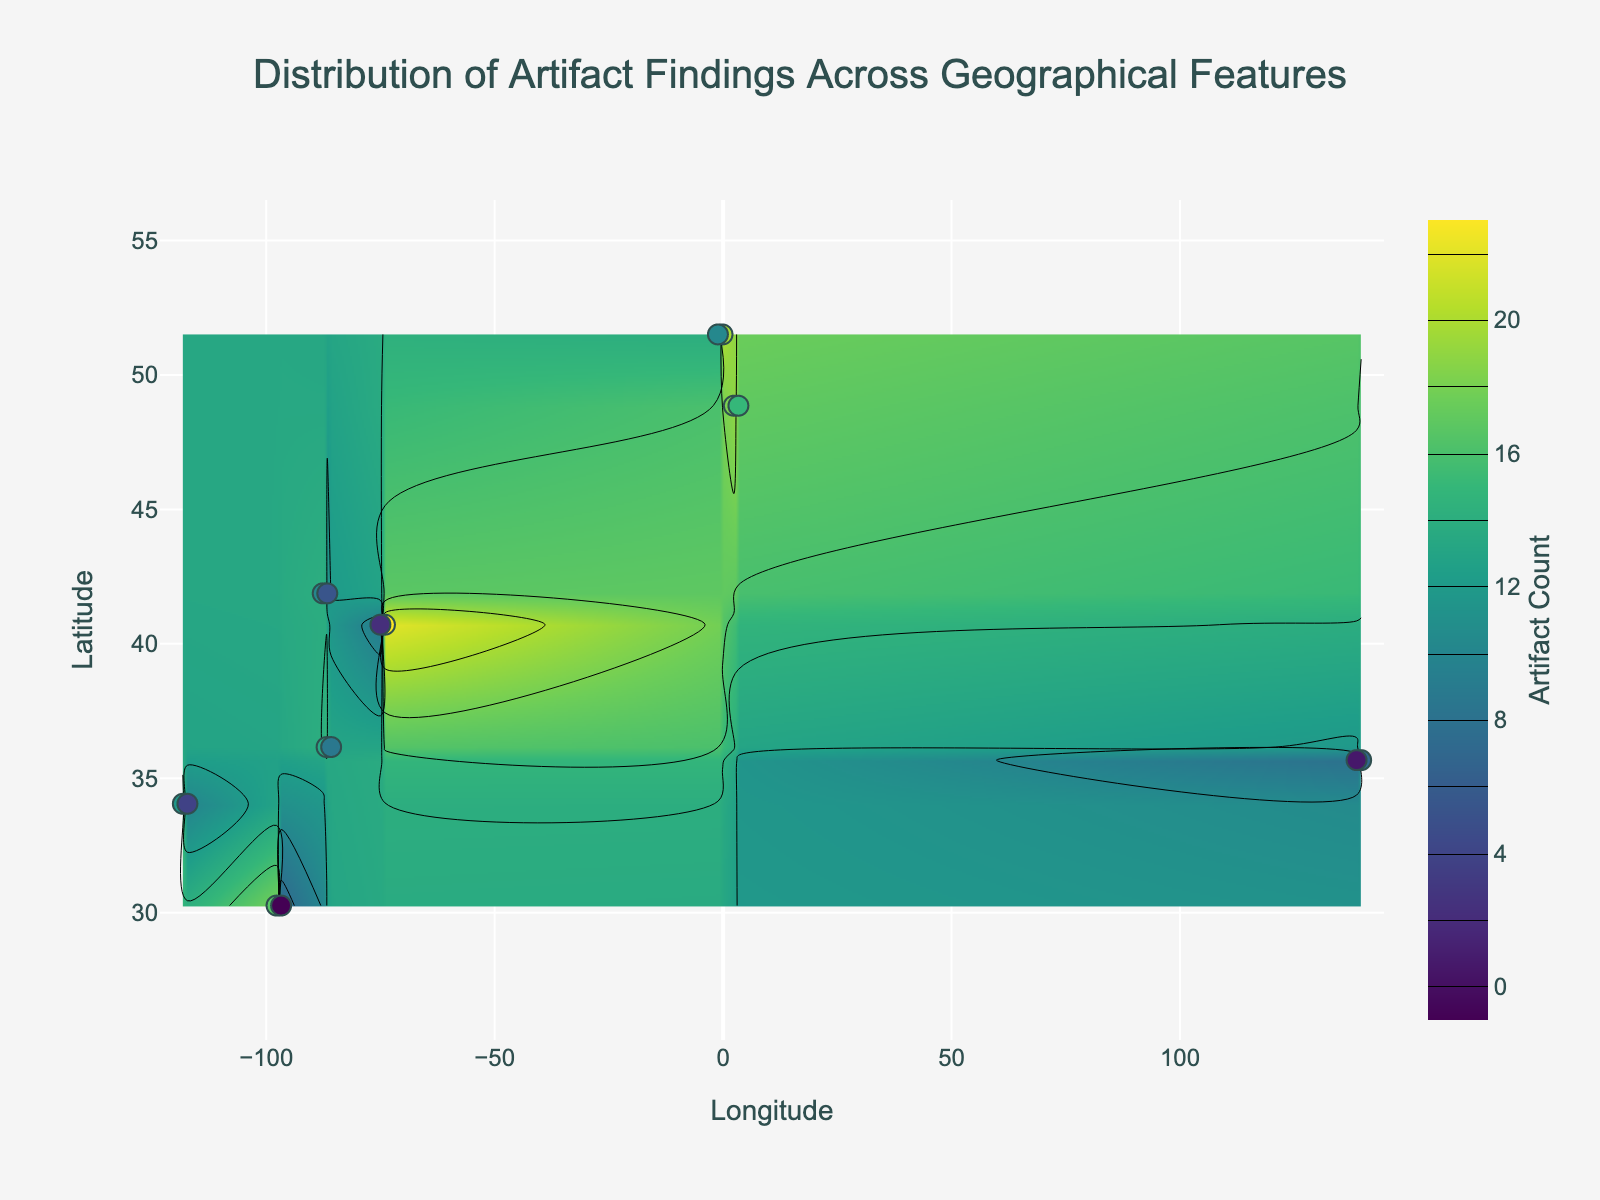what is the highest number of artifacts found in any location? The color bar title "Artifact Count" on the right side of the figure, combined with contours on the graph, indicates that the highest artifact count is visible around the geographical points with the most intense color (which represents high values). By examining the scale of the color bar and the color intensity, it can be deduced that the highest number is 22.
Answer: 22 What geographical feature is located at Lat 40.7128, Long -74.0060? By observing the scatter points overlaying the contour plot and checking the hover information for the specific latitude 40.7128 and longitude -74.0060, the geographical feature corresponding to this point is "Urban Ruins".
Answer: Urban Ruins How many different geographical features are represented in the figure? Evaluating the scatter plot, where each point is associated with a specific geographical feature indicated through hover information, reveals distinct geographical features including Valley, Plain, Riverbank, Hill, Urban Ruins, Forest, and Mountain Base. Counting these distinct features provides the answer.
Answer: 7 Are the artifacts more densely found near riverbanks or forests? By comparing the color intensities and artifact counts in locations labeled as "Riverbank" and "Forest" on the scatter plot and contour map, riverbanks (e.g., artifact counts of 20, 17, and 10) generally show higher densities compared to forests (e.g., artifact counts of 16 and 8).
Answer: Riverbanks What is the range of artifact counts depicted in the contour plot? The contour intervals and the color bar can be analyzed to determine the total range of artifact counts. Contours suggest a minimum of 7 artifacts and a maximum of 22 artifacts.
Answer: 7 - 22 Which peak contains more artifacts: the hill at Lat 30.2672, Long -97.7431 or the mountain base at Lat 48.8566, Long 2.3522? Observing the scatter plot, the artifact counts associated with Hill (18 artifacts) and Mountain Base (19 artifacts) locations, as represented by their marker color and labeled hover information, show that the Mountain Base contains more artifacts.
Answer: Mountain Base Between Lat 34.0522, Long -118.2437 and Lat 34.0522, Long -117.2437, which location has a higher artifact count? Checking the hover information over the specific lattice coordinates reveals that Lat 34.0522, Long -118.2437 has 15 artifacts whereas Lat 34.0522, Long -117.2437 has 10 artifacts. Therefore, the first location has a higher artifact count.
Answer: Lat 34.0522, Long -118.2437 What is the average number of artifacts found in Urban Ruins? Urban Ruins feature is associated with the artifact counts of 22 and 9. Summing these values yields 31, and dividing by 2 data points results in an average of 15.5 artifacts.
Answer: 15.5 